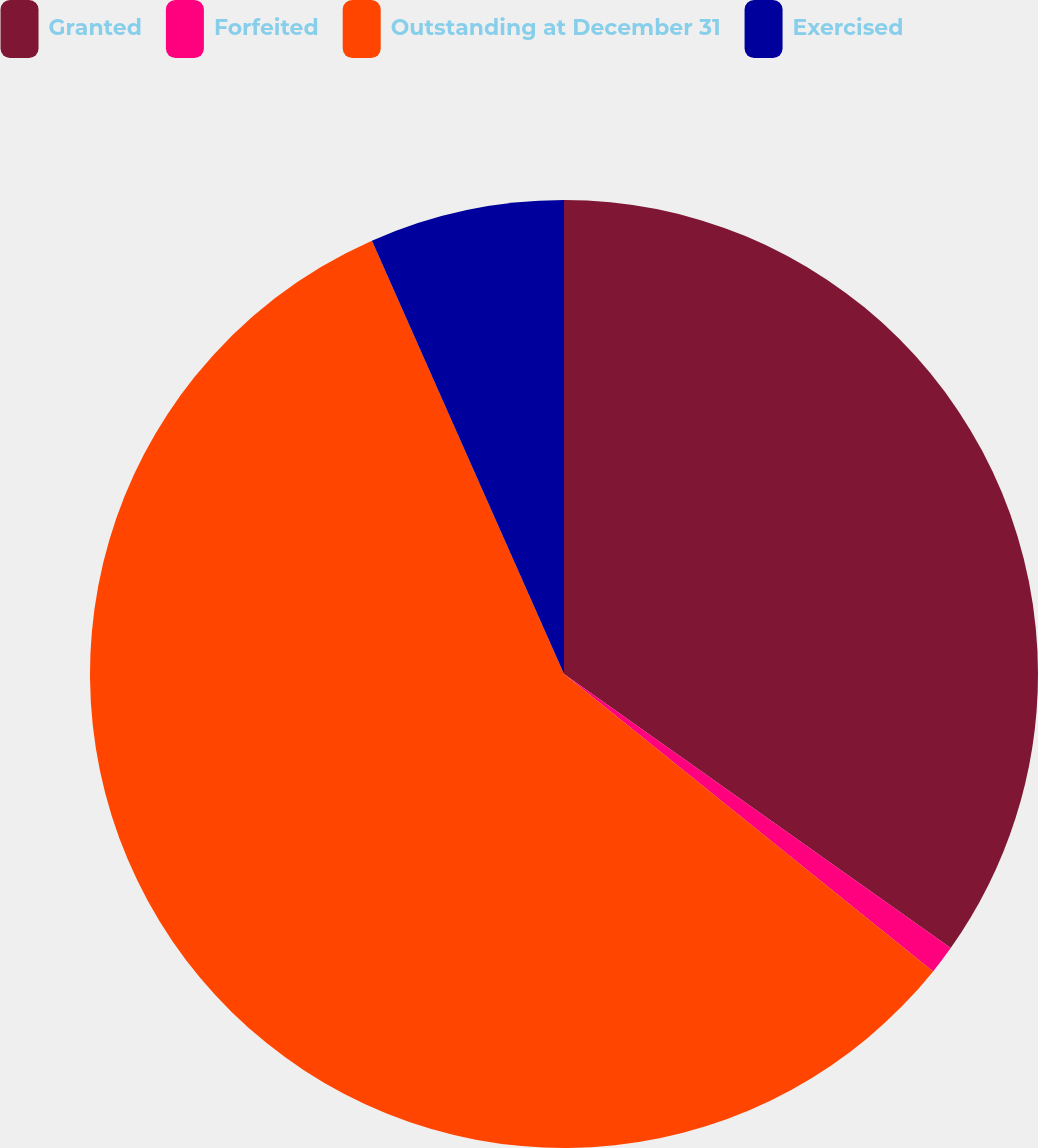Convert chart to OTSL. <chart><loc_0><loc_0><loc_500><loc_500><pie_chart><fcel>Granted<fcel>Forfeited<fcel>Outstanding at December 31<fcel>Exercised<nl><fcel>34.81%<fcel>0.98%<fcel>57.56%<fcel>6.64%<nl></chart> 